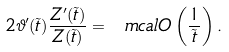Convert formula to latex. <formula><loc_0><loc_0><loc_500><loc_500>2 \vartheta ^ { \prime } ( \tilde { t } ) \frac { Z ^ { \prime } ( \tilde { t } ) } { Z ( \tilde { t } ) } = \ m c a l { O } \left ( \frac { 1 } { \tilde { t } } \right ) .</formula> 